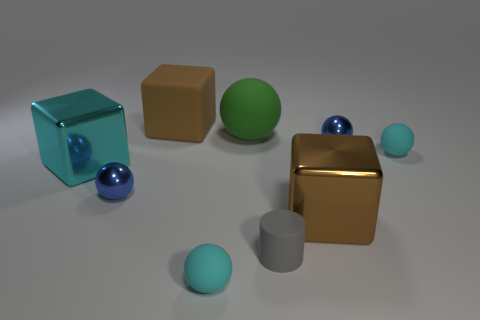There is a cyan metal object; is its size the same as the brown block behind the large green ball?
Keep it short and to the point. Yes. There is a matte object that is the same size as the green rubber sphere; what is its color?
Give a very brief answer. Brown. The gray matte cylinder is what size?
Offer a very short reply. Small. Do the blue sphere that is in front of the cyan block and the green ball have the same material?
Provide a succinct answer. No. Is the big green matte object the same shape as the large cyan shiny thing?
Your answer should be very brief. No. There is a tiny blue object that is in front of the small matte sphere to the right of the tiny cyan rubber ball that is on the left side of the big green object; what shape is it?
Your answer should be very brief. Sphere. Do the metallic object that is behind the big cyan object and the brown object that is on the right side of the big green matte object have the same shape?
Keep it short and to the point. No. Is there a big green object made of the same material as the tiny cylinder?
Give a very brief answer. Yes. There is a tiny ball that is to the left of the brown object behind the large cube left of the brown matte cube; what is its color?
Give a very brief answer. Blue. Is the thing behind the green thing made of the same material as the blue thing that is to the left of the big brown shiny thing?
Offer a very short reply. No. 